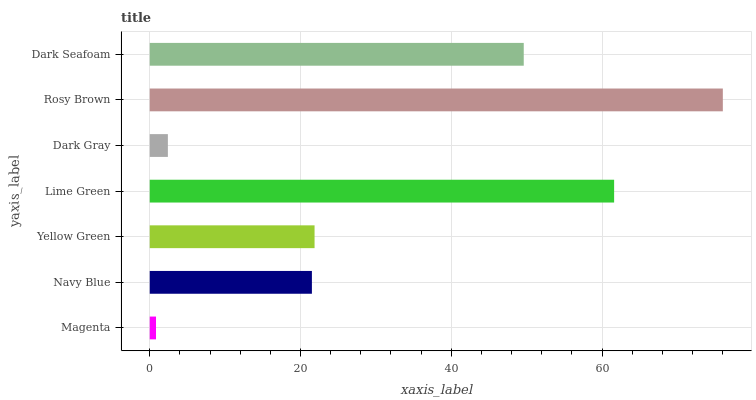Is Magenta the minimum?
Answer yes or no. Yes. Is Rosy Brown the maximum?
Answer yes or no. Yes. Is Navy Blue the minimum?
Answer yes or no. No. Is Navy Blue the maximum?
Answer yes or no. No. Is Navy Blue greater than Magenta?
Answer yes or no. Yes. Is Magenta less than Navy Blue?
Answer yes or no. Yes. Is Magenta greater than Navy Blue?
Answer yes or no. No. Is Navy Blue less than Magenta?
Answer yes or no. No. Is Yellow Green the high median?
Answer yes or no. Yes. Is Yellow Green the low median?
Answer yes or no. Yes. Is Navy Blue the high median?
Answer yes or no. No. Is Dark Gray the low median?
Answer yes or no. No. 